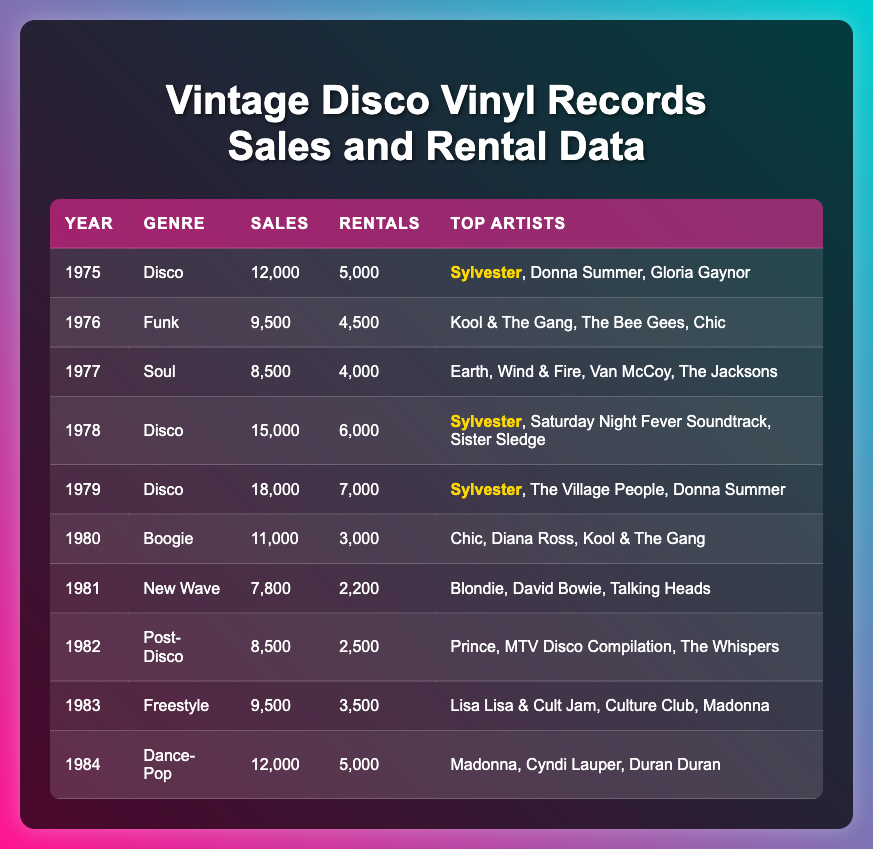What year had the highest disco sales? The table shows that 1979 had the highest sales for the disco genre, with 18,000 records sold.
Answer: 1979 How many rentals were recorded in 1980? By checking the data for the year 1980, we can see there were 3,000 rentals recorded.
Answer: 3,000 Which genre had the lowest sales in the table? By comparing sales across all genres and years, the genre with the lowest sales is New Wave in 1981 with 7,800 records.
Answer: New Wave What is the total number of sales for disco records from 1975 to 1979? Adding up disco sales: 12,000 (1975) + 15,000 (1978) + 18,000 (1979) = 45,000.
Answer: 45,000 Did any of the top artists appear more than once in disco records sales? Yes, Sylvester appears in both 1975 and 1978 alongside other artists.
Answer: Yes What is the average number of rentals across all years? To find the average, sum all rentals: 5,000 + 4,500 + 4,000 + 6,000 + 7,000 + 3,000 + 2,200 + 2,500 + 3,500 + 5,000 = 43,700. There are 10 years, so 43,700 / 10 = 4,370.
Answer: 4,370 In which year did the highest number of rentals occur? Observing the data shows that 1979 recorded the highest rentals at 7,000.
Answer: 1979 What was the difference in sales between 1977 and 1978? The sales in 1978 were 15,000 and in 1977 were 8,500. The difference is 15,000 - 8,500 = 6,500.
Answer: 6,500 Which year had both the highest sales and the highest rentals for disco records? 1979 had the highest sales of 18,000 and highest rentals of 7,000 for disco records.
Answer: 1979 How many top artists are listed for the year 1984? The entries for 1984 indicate there are three top artists: Madonna, Cyndi Lauper, and Duran Duran.
Answer: 3 